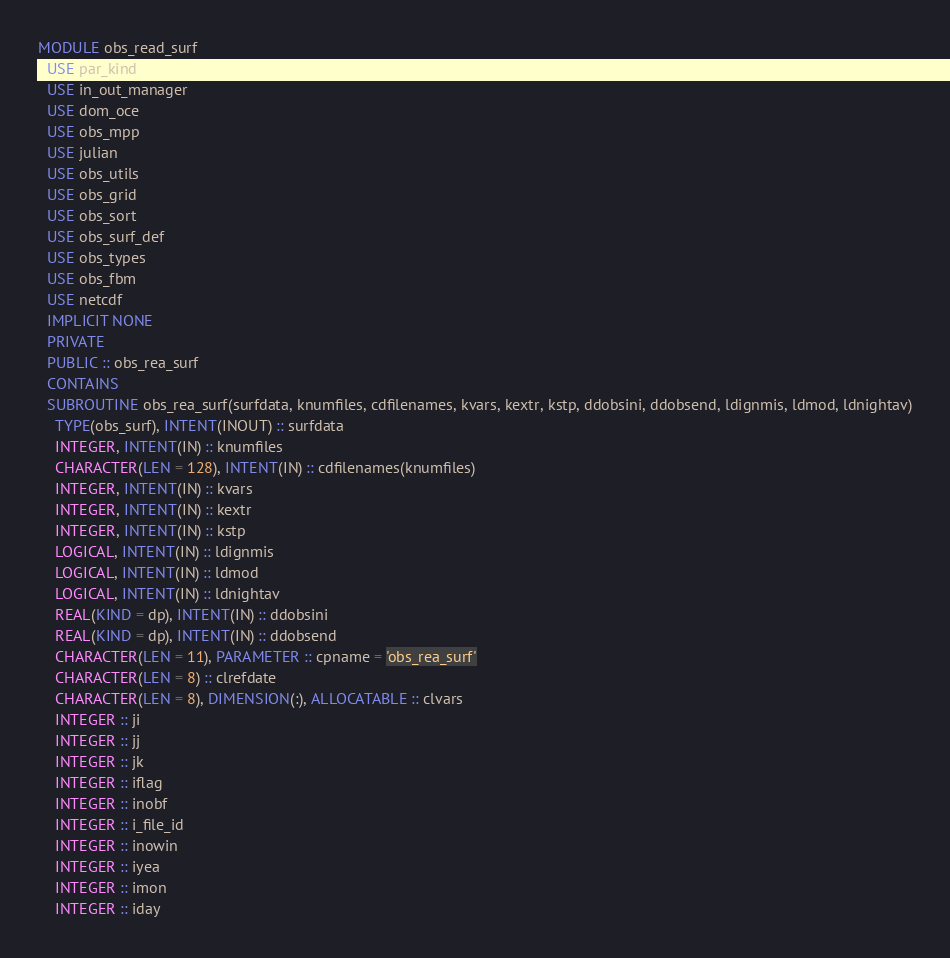<code> <loc_0><loc_0><loc_500><loc_500><_FORTRAN_>MODULE obs_read_surf
  USE par_kind
  USE in_out_manager
  USE dom_oce
  USE obs_mpp
  USE julian
  USE obs_utils
  USE obs_grid
  USE obs_sort
  USE obs_surf_def
  USE obs_types
  USE obs_fbm
  USE netcdf
  IMPLICIT NONE
  PRIVATE
  PUBLIC :: obs_rea_surf
  CONTAINS
  SUBROUTINE obs_rea_surf(surfdata, knumfiles, cdfilenames, kvars, kextr, kstp, ddobsini, ddobsend, ldignmis, ldmod, ldnightav)
    TYPE(obs_surf), INTENT(INOUT) :: surfdata
    INTEGER, INTENT(IN) :: knumfiles
    CHARACTER(LEN = 128), INTENT(IN) :: cdfilenames(knumfiles)
    INTEGER, INTENT(IN) :: kvars
    INTEGER, INTENT(IN) :: kextr
    INTEGER, INTENT(IN) :: kstp
    LOGICAL, INTENT(IN) :: ldignmis
    LOGICAL, INTENT(IN) :: ldmod
    LOGICAL, INTENT(IN) :: ldnightav
    REAL(KIND = dp), INTENT(IN) :: ddobsini
    REAL(KIND = dp), INTENT(IN) :: ddobsend
    CHARACTER(LEN = 11), PARAMETER :: cpname = 'obs_rea_surf'
    CHARACTER(LEN = 8) :: clrefdate
    CHARACTER(LEN = 8), DIMENSION(:), ALLOCATABLE :: clvars
    INTEGER :: ji
    INTEGER :: jj
    INTEGER :: jk
    INTEGER :: iflag
    INTEGER :: inobf
    INTEGER :: i_file_id
    INTEGER :: inowin
    INTEGER :: iyea
    INTEGER :: imon
    INTEGER :: iday</code> 